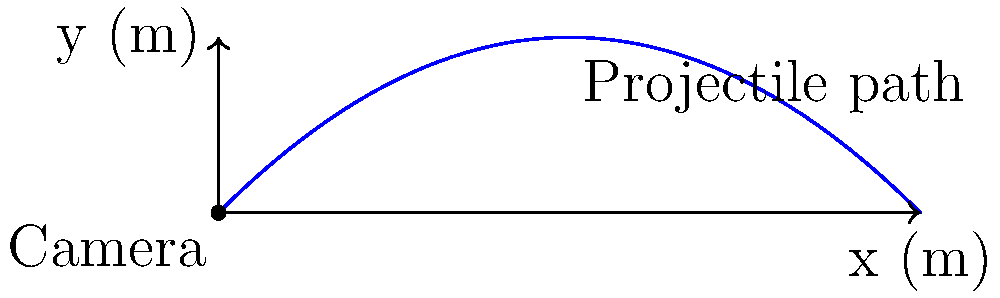In a groundbreaking international film collaboration, a cinematographer wants to capture a unique aerial shot of a projectile's trajectory. The camera is positioned at ground level, and the projectile is launched at an angle of 45° with an initial velocity of 30 m/s. Assuming ideal conditions, what is the maximum height reached by the projectile, and how does this relate to framing the shot for maximum visual impact? To solve this problem, we'll follow these steps:

1) The maximum height of a projectile launched at an angle is given by the formula:

   $$h_{max} = \frac{(v_0 \sin \theta)^2}{2g}$$

   Where:
   $v_0$ is the initial velocity
   $\theta$ is the launch angle
   $g$ is the acceleration due to gravity (9.8 m/s²)

2) We're given:
   $v_0 = 30$ m/s
   $\theta = 45°$

3) First, let's calculate $\sin 45°$:
   $\sin 45° = \frac{\sqrt{2}}{2} \approx 0.707$

4) Now, let's substitute these values into our equation:

   $$h_{max} = \frac{(30 \cdot 0.707)^2}{2 \cdot 9.8}$$

5) Simplify:
   $$h_{max} = \frac{449.82}{19.6} \approx 22.95 \text{ m}$$

6) Relating to cinematography:
   - The maximum height of 22.95 m provides a reference for framing the shot.
   - The cinematographer should ensure the camera's field of view encompasses at least 23 m vertically to capture the entire trajectory.
   - This height can be used to determine the appropriate lens and camera positioning for the desired visual effect.
   - Understanding the projectile's path allows for creative shot composition, potentially capturing the apex of the trajectory at a dramatically effective point in the frame.
Answer: 22.95 m; frame shot to encompass at least 23 m vertically 